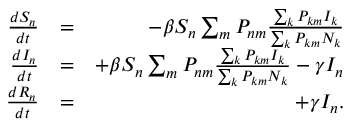Convert formula to latex. <formula><loc_0><loc_0><loc_500><loc_500>\begin{array} { r l r } { \frac { d S _ { n } } { d t } } & { = } & { - \beta S _ { n } \sum _ { m } P _ { n m } \frac { \sum _ { k } P _ { k m } I _ { k } } { \sum _ { k } P _ { k m } N _ { k } } } \\ { \frac { d I _ { n } } { d t } } & { = } & { + \beta S _ { n } \sum _ { m } P _ { n m } \frac { \sum _ { k } P _ { k m } I _ { k } } { \sum _ { k } P _ { k m } N _ { k } } - \gamma I _ { n } } \\ { \frac { d R _ { n } } { d t } } & { = } & { + \gamma I _ { n } . } \end{array}</formula> 